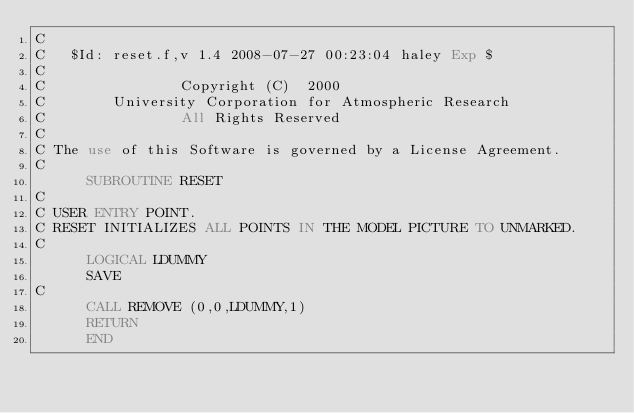Convert code to text. <code><loc_0><loc_0><loc_500><loc_500><_FORTRAN_>C
C	$Id: reset.f,v 1.4 2008-07-27 00:23:04 haley Exp $
C                                                                      
C                Copyright (C)  2000
C        University Corporation for Atmospheric Research
C                All Rights Reserved
C
C The use of this Software is governed by a License Agreement.
C
      SUBROUTINE RESET
C
C USER ENTRY POINT.
C RESET INITIALIZES ALL POINTS IN THE MODEL PICTURE TO UNMARKED.
C
      LOGICAL LDUMMY
      SAVE
C
      CALL REMOVE (0,0,LDUMMY,1)
      RETURN
      END
</code> 